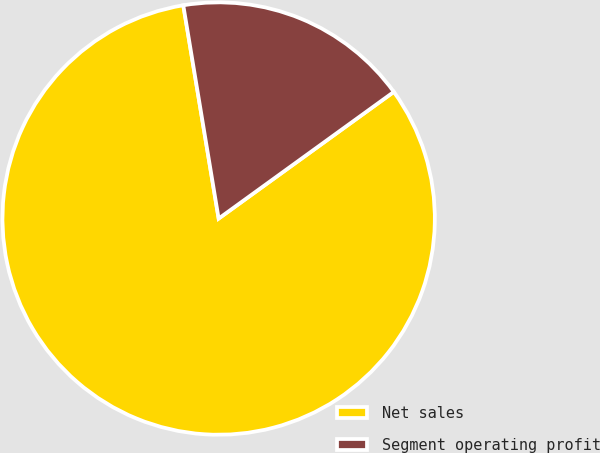Convert chart. <chart><loc_0><loc_0><loc_500><loc_500><pie_chart><fcel>Net sales<fcel>Segment operating profit<nl><fcel>82.35%<fcel>17.65%<nl></chart> 